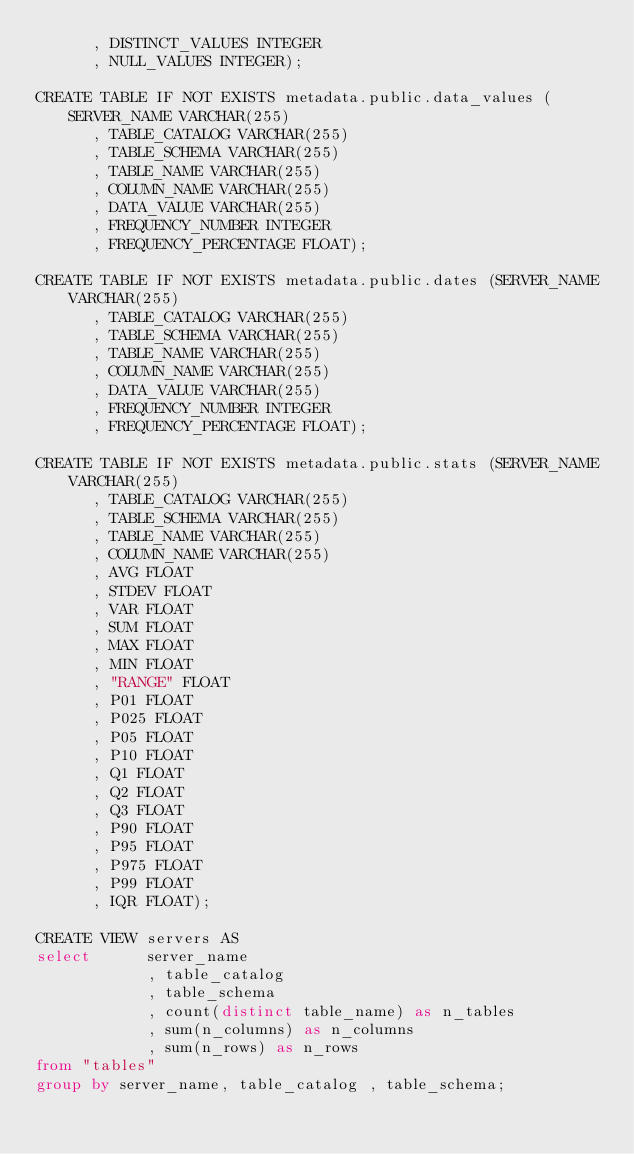Convert code to text. <code><loc_0><loc_0><loc_500><loc_500><_SQL_>      , DISTINCT_VALUES INTEGER
      , NULL_VALUES INTEGER);

CREATE TABLE IF NOT EXISTS metadata.public.data_values (SERVER_NAME VARCHAR(255)
      , TABLE_CATALOG VARCHAR(255)
      , TABLE_SCHEMA VARCHAR(255)
      , TABLE_NAME VARCHAR(255)
      , COLUMN_NAME VARCHAR(255)
      , DATA_VALUE VARCHAR(255)
      , FREQUENCY_NUMBER INTEGER
      , FREQUENCY_PERCENTAGE FLOAT);

CREATE TABLE IF NOT EXISTS metadata.public.dates (SERVER_NAME VARCHAR(255)
      , TABLE_CATALOG VARCHAR(255)
      , TABLE_SCHEMA VARCHAR(255)
      , TABLE_NAME VARCHAR(255)
      , COLUMN_NAME VARCHAR(255)
      , DATA_VALUE VARCHAR(255)
      , FREQUENCY_NUMBER INTEGER
      , FREQUENCY_PERCENTAGE FLOAT);

CREATE TABLE IF NOT EXISTS metadata.public.stats (SERVER_NAME VARCHAR(255)
      , TABLE_CATALOG VARCHAR(255)
      , TABLE_SCHEMA VARCHAR(255)
      , TABLE_NAME VARCHAR(255)
      , COLUMN_NAME VARCHAR(255)
      , AVG FLOAT
      , STDEV FLOAT
      , VAR FLOAT
      , SUM FLOAT
      , MAX FLOAT
      , MIN FLOAT
      , "RANGE" FLOAT
      , P01 FLOAT
      , P025 FLOAT
      , P05 FLOAT
      , P10 FLOAT
      , Q1 FLOAT
      , Q2 FLOAT
      , Q3 FLOAT
      , P90 FLOAT
      , P95 FLOAT
      , P975 FLOAT
      , P99 FLOAT
      , IQR FLOAT);

CREATE VIEW servers AS 
select      server_name
            , table_catalog
            , table_schema
            , count(distinct table_name) as n_tables
            , sum(n_columns) as n_columns
            , sum(n_rows) as n_rows 
from "tables" 
group by server_name, table_catalog , table_schema;</code> 